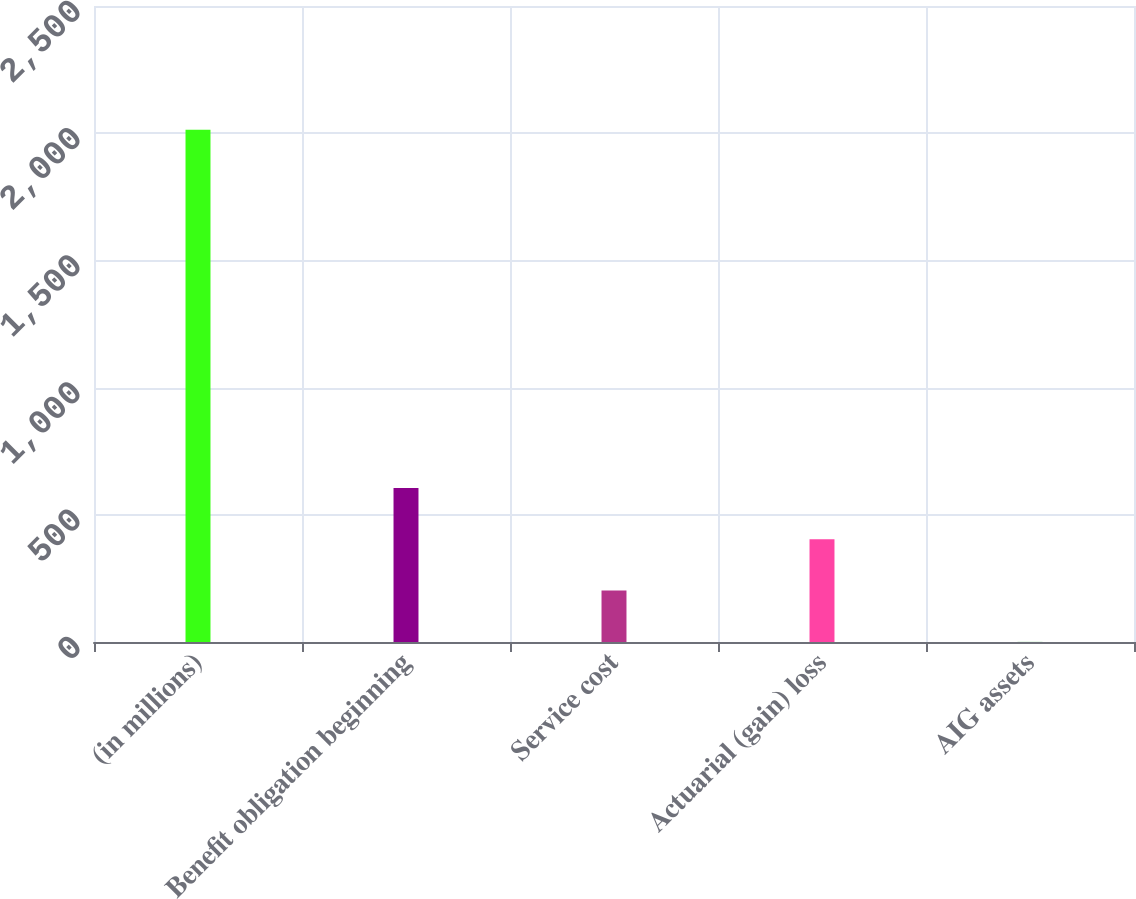Convert chart. <chart><loc_0><loc_0><loc_500><loc_500><bar_chart><fcel>(in millions)<fcel>Benefit obligation beginning<fcel>Service cost<fcel>Actuarial (gain) loss<fcel>AIG assets<nl><fcel>2014<fcel>604.9<fcel>202.3<fcel>403.6<fcel>1<nl></chart> 